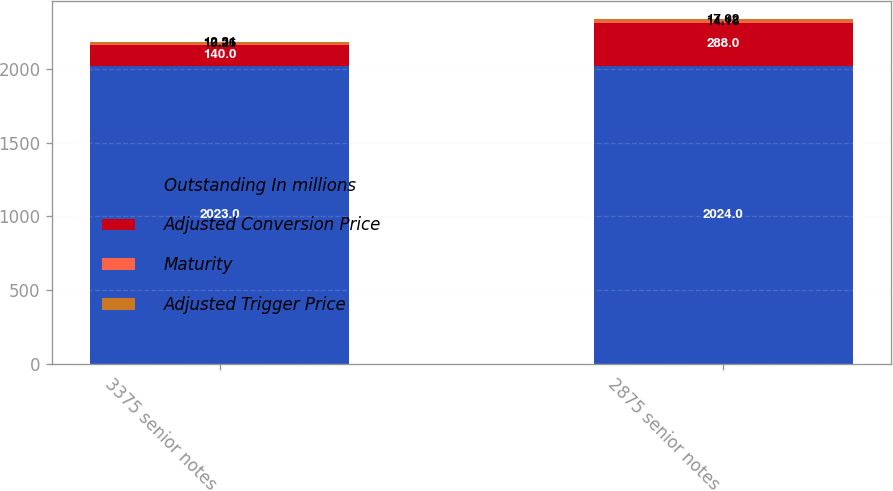Convert chart. <chart><loc_0><loc_0><loc_500><loc_500><stacked_bar_chart><ecel><fcel>3375 senior notes<fcel>2875 senior notes<nl><fcel>Outstanding In millions<fcel>2023<fcel>2024<nl><fcel>Adjusted Conversion Price<fcel>140<fcel>288<nl><fcel>Maturity<fcel>10.26<fcel>14.18<nl><fcel>Adjusted Trigger Price<fcel>12.31<fcel>17.02<nl></chart> 